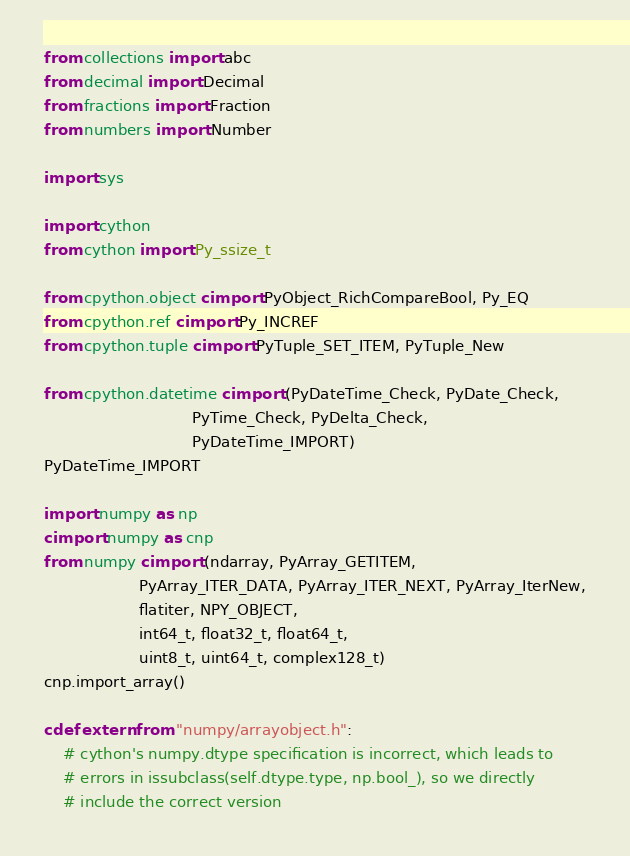Convert code to text. <code><loc_0><loc_0><loc_500><loc_500><_Cython_>from collections import abc
from decimal import Decimal
from fractions import Fraction
from numbers import Number

import sys

import cython
from cython import Py_ssize_t

from cpython.object cimport PyObject_RichCompareBool, Py_EQ
from cpython.ref cimport Py_INCREF
from cpython.tuple cimport PyTuple_SET_ITEM, PyTuple_New

from cpython.datetime cimport (PyDateTime_Check, PyDate_Check,
                               PyTime_Check, PyDelta_Check,
                               PyDateTime_IMPORT)
PyDateTime_IMPORT

import numpy as np
cimport numpy as cnp
from numpy cimport (ndarray, PyArray_GETITEM,
                    PyArray_ITER_DATA, PyArray_ITER_NEXT, PyArray_IterNew,
                    flatiter, NPY_OBJECT,
                    int64_t, float32_t, float64_t,
                    uint8_t, uint64_t, complex128_t)
cnp.import_array()

cdef extern from "numpy/arrayobject.h":
    # cython's numpy.dtype specification is incorrect, which leads to
    # errors in issubclass(self.dtype.type, np.bool_), so we directly
    # include the correct version</code> 